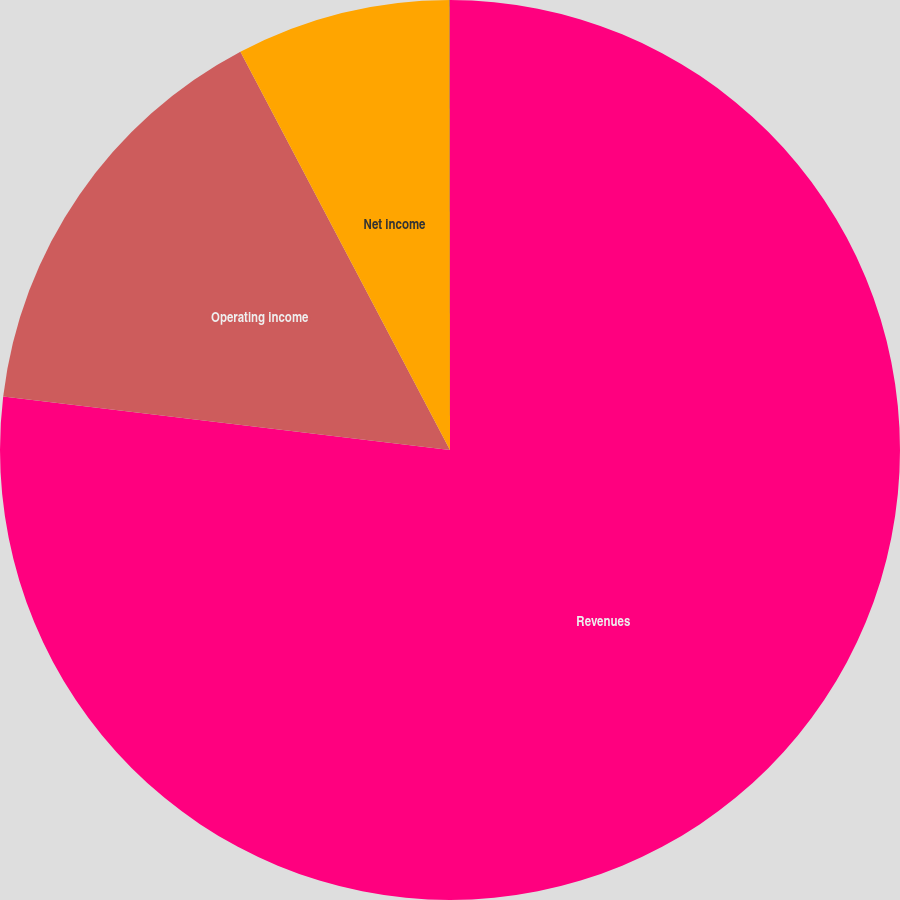<chart> <loc_0><loc_0><loc_500><loc_500><pie_chart><fcel>Revenues<fcel>Operating income<fcel>Net income<fcel>Diluted earnings per share<nl><fcel>76.89%<fcel>15.39%<fcel>7.7%<fcel>0.01%<nl></chart> 